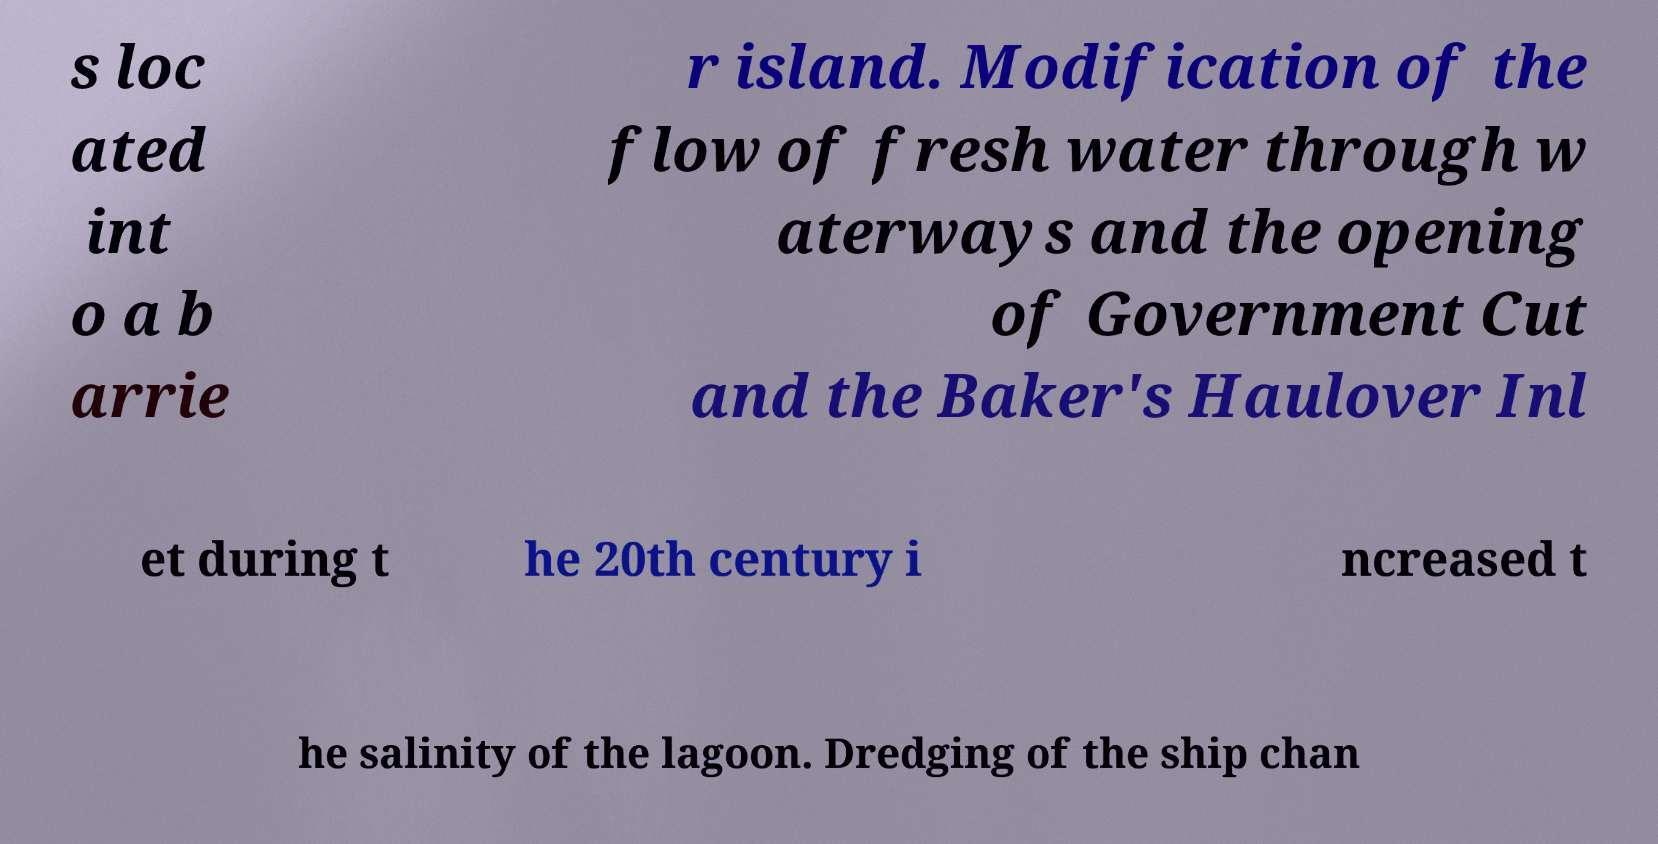There's text embedded in this image that I need extracted. Can you transcribe it verbatim? s loc ated int o a b arrie r island. Modification of the flow of fresh water through w aterways and the opening of Government Cut and the Baker's Haulover Inl et during t he 20th century i ncreased t he salinity of the lagoon. Dredging of the ship chan 